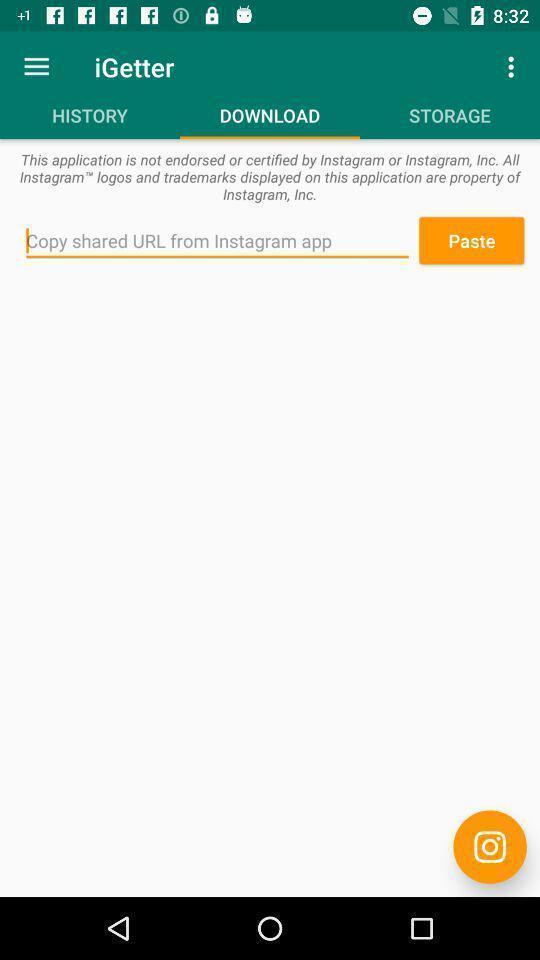What is the overall content of this screenshot? Screen showing paste option. 